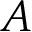Convert formula to latex. <formula><loc_0><loc_0><loc_500><loc_500>A</formula> 